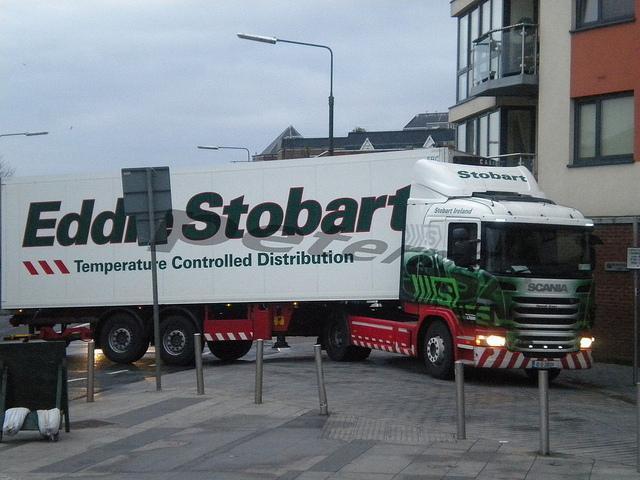How many "do not U turn" signs are there in this picture?
Give a very brief answer. 0. How many doors in this?
Give a very brief answer. 1. How many smoke stacks does the truck have?
Give a very brief answer. 0. How many trailers are there?
Give a very brief answer. 1. 